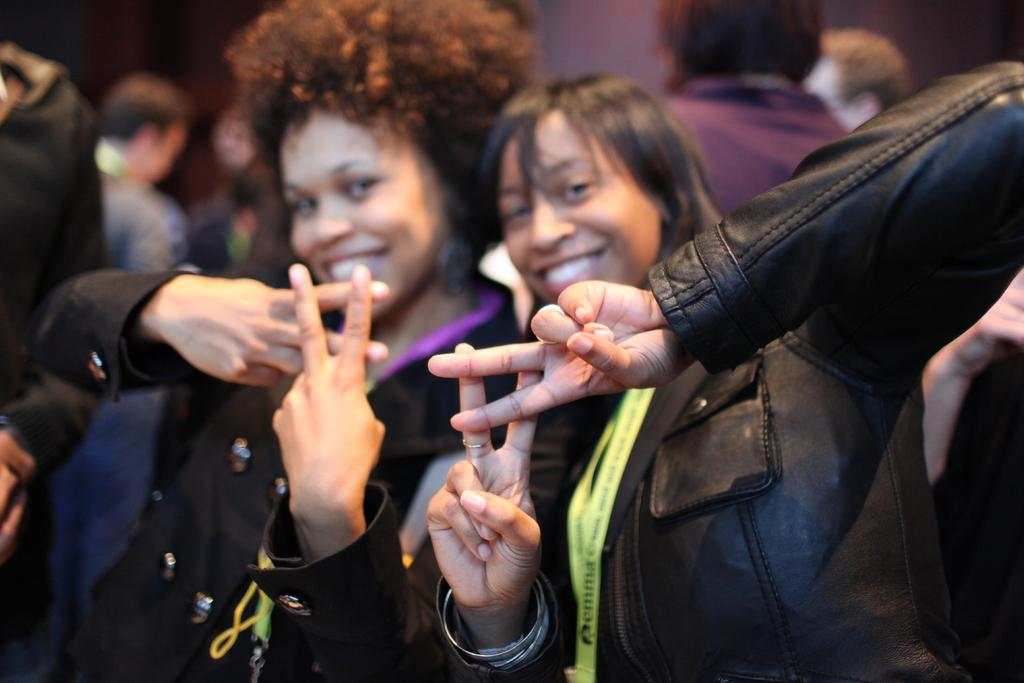How many people are in the picture? There are two women in the picture. What are the women doing in the picture? The women are posing for a photo. What are the women wearing in the picture? The women are wearing black jackets. Can you describe the background of the women in the picture? The background of the women is blurred. What type of root can be seen growing in the picture? There is no root present in the picture; it features two women posing for a photo. How much honey is visible in the picture? There is no honey present in the picture. 